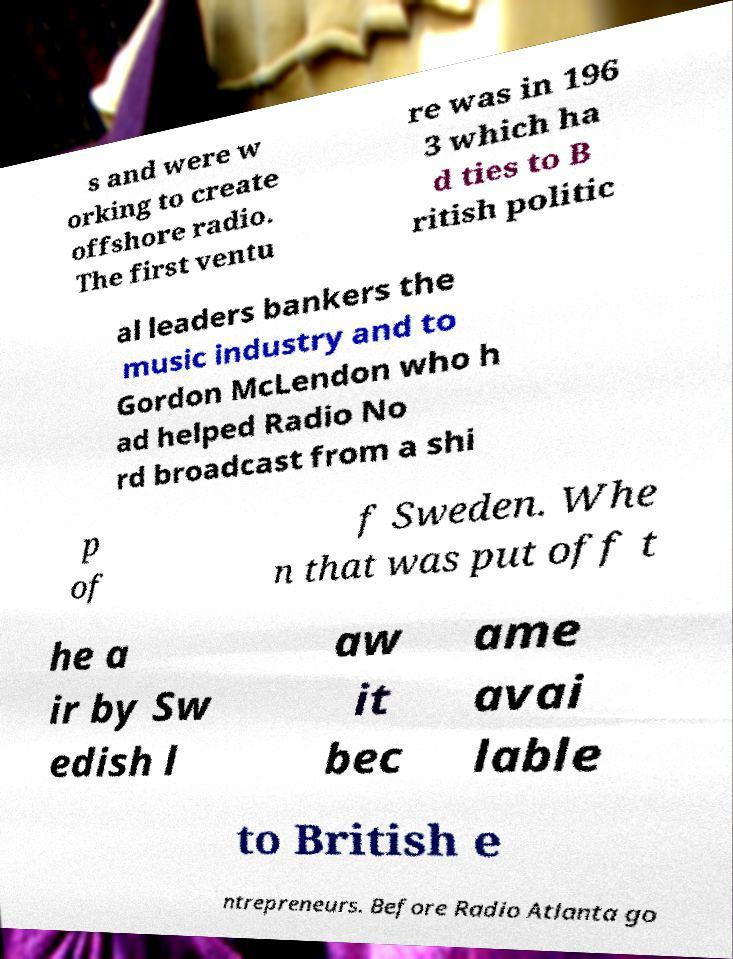I need the written content from this picture converted into text. Can you do that? s and were w orking to create offshore radio. The first ventu re was in 196 3 which ha d ties to B ritish politic al leaders bankers the music industry and to Gordon McLendon who h ad helped Radio No rd broadcast from a shi p of f Sweden. Whe n that was put off t he a ir by Sw edish l aw it bec ame avai lable to British e ntrepreneurs. Before Radio Atlanta go 